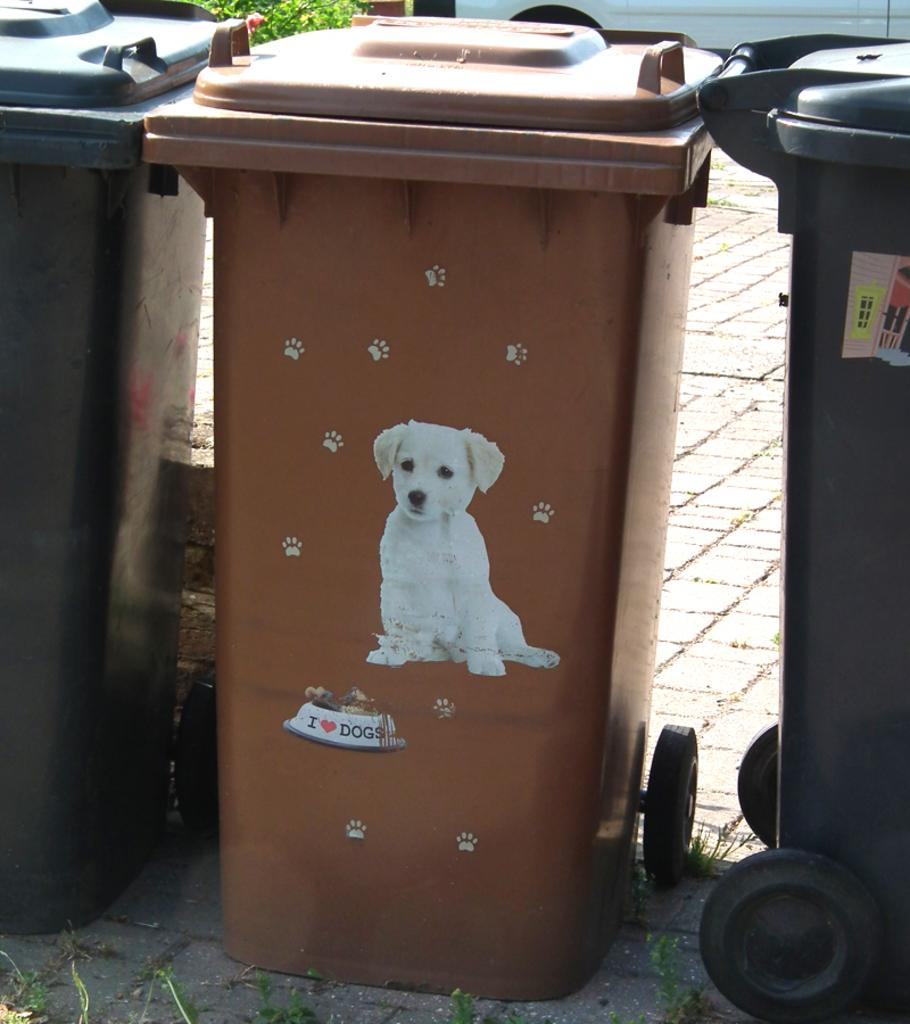Provide a one-sentence caption for the provided image. Brown garbage can which says I Love Dogs on it. 